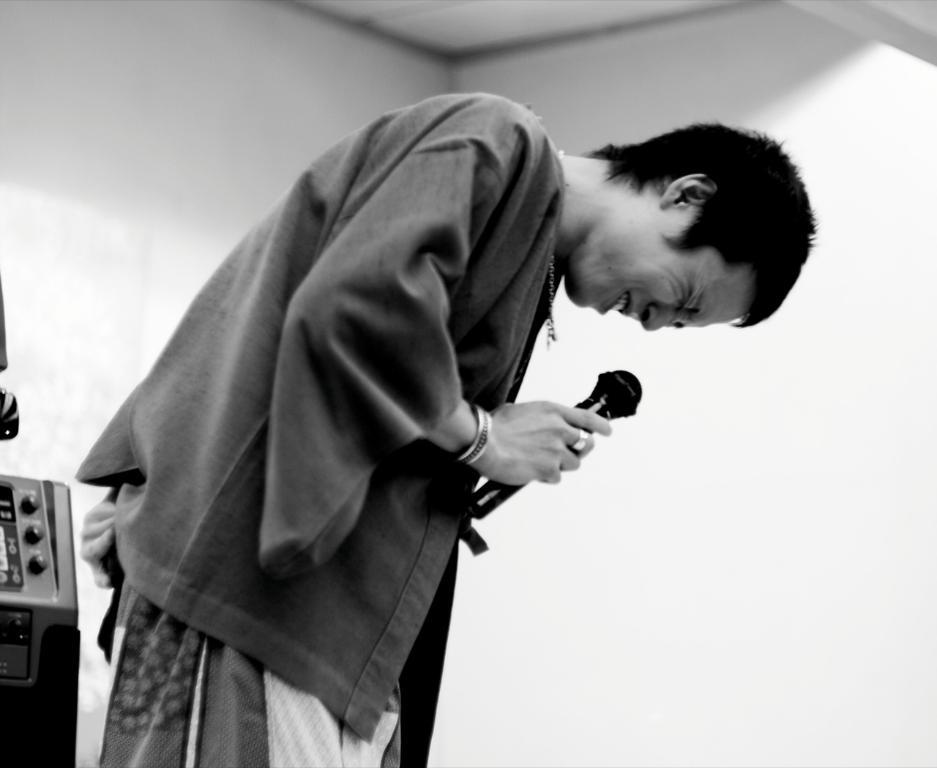What is the person in the image doing? The person is standing in the image and holding a microphone. What can be seen in the background of the image? There is a wall in the background of the image. What type of vest is the person wearing in the image? There is no vest visible in the image; the person is only holding a microphone. How hot is the microphone in the image? The temperature of the microphone cannot be determined from the image, as it is a visual representation and not a thermal one. 